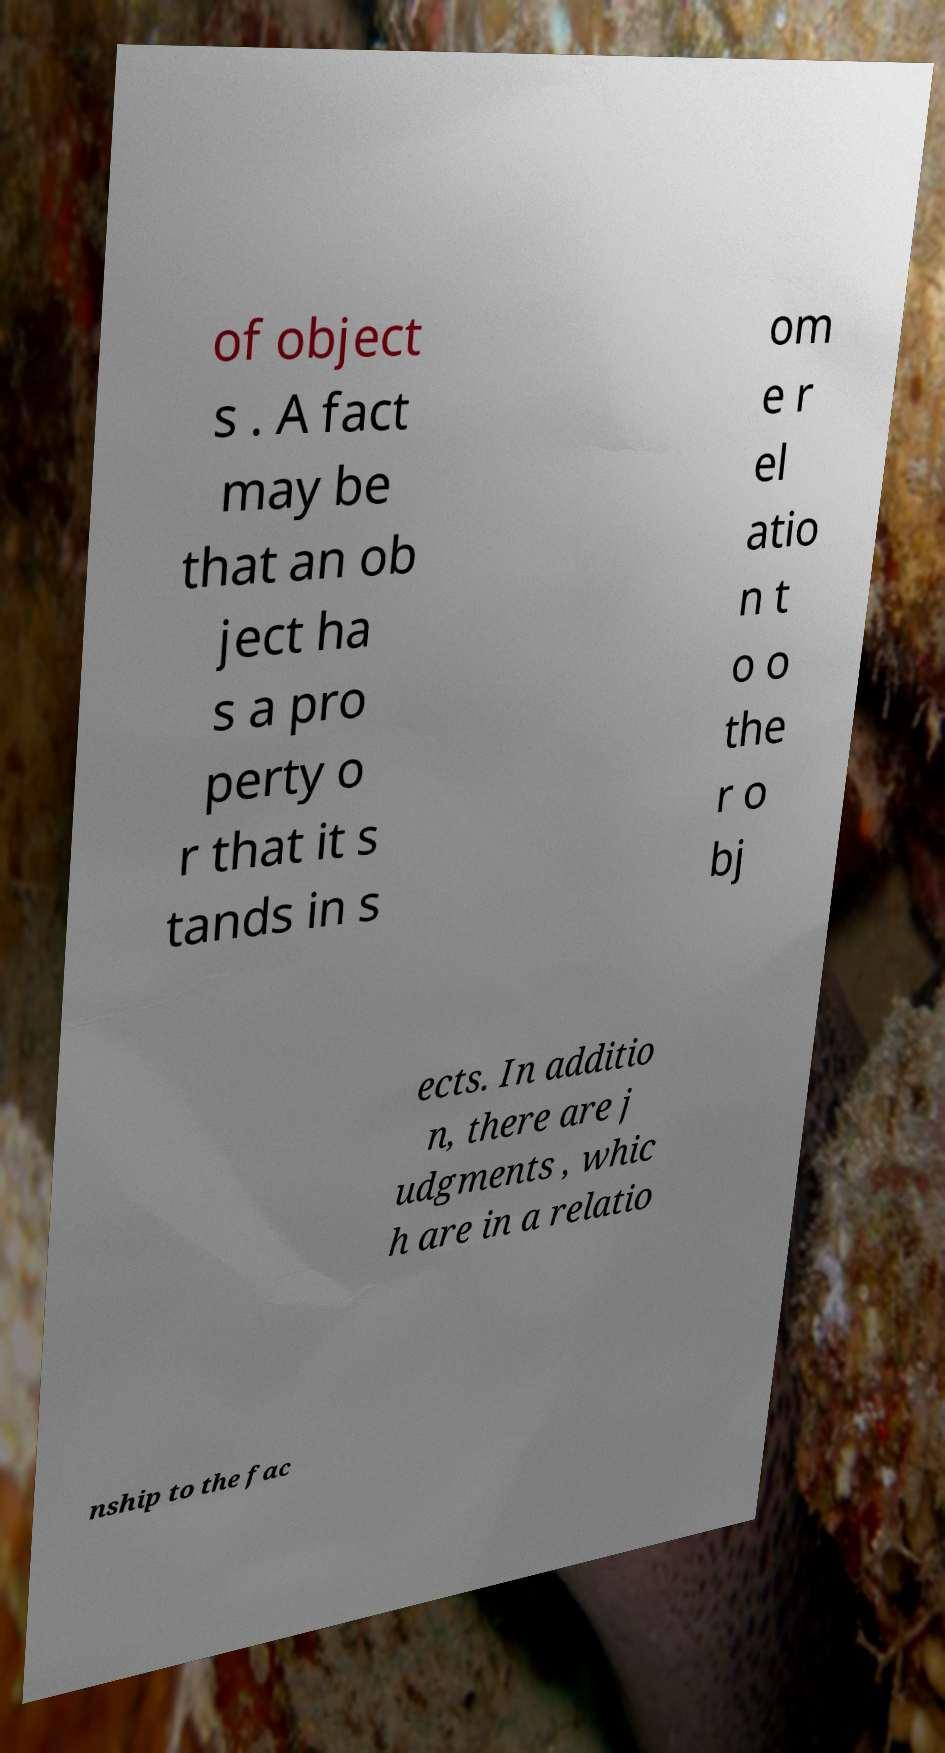Please read and relay the text visible in this image. What does it say? of object s . A fact may be that an ob ject ha s a pro perty o r that it s tands in s om e r el atio n t o o the r o bj ects. In additio n, there are j udgments , whic h are in a relatio nship to the fac 